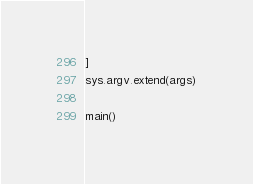Convert code to text. <code><loc_0><loc_0><loc_500><loc_500><_Python_>
]
sys.argv.extend(args)

main()
</code> 